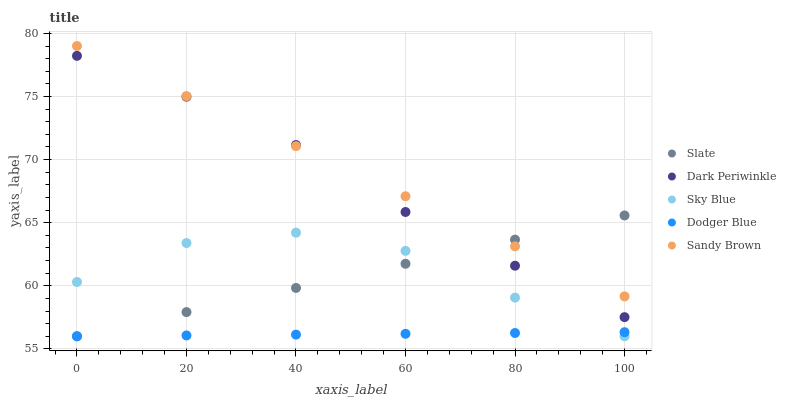Does Dodger Blue have the minimum area under the curve?
Answer yes or no. Yes. Does Sandy Brown have the maximum area under the curve?
Answer yes or no. Yes. Does Slate have the minimum area under the curve?
Answer yes or no. No. Does Slate have the maximum area under the curve?
Answer yes or no. No. Is Dodger Blue the smoothest?
Answer yes or no. Yes. Is Sky Blue the roughest?
Answer yes or no. Yes. Is Slate the smoothest?
Answer yes or no. No. Is Slate the roughest?
Answer yes or no. No. Does Sky Blue have the lowest value?
Answer yes or no. Yes. Does Dark Periwinkle have the lowest value?
Answer yes or no. No. Does Sandy Brown have the highest value?
Answer yes or no. Yes. Does Slate have the highest value?
Answer yes or no. No. Is Sky Blue less than Dark Periwinkle?
Answer yes or no. Yes. Is Sandy Brown greater than Dodger Blue?
Answer yes or no. Yes. Does Dark Periwinkle intersect Slate?
Answer yes or no. Yes. Is Dark Periwinkle less than Slate?
Answer yes or no. No. Is Dark Periwinkle greater than Slate?
Answer yes or no. No. Does Sky Blue intersect Dark Periwinkle?
Answer yes or no. No. 